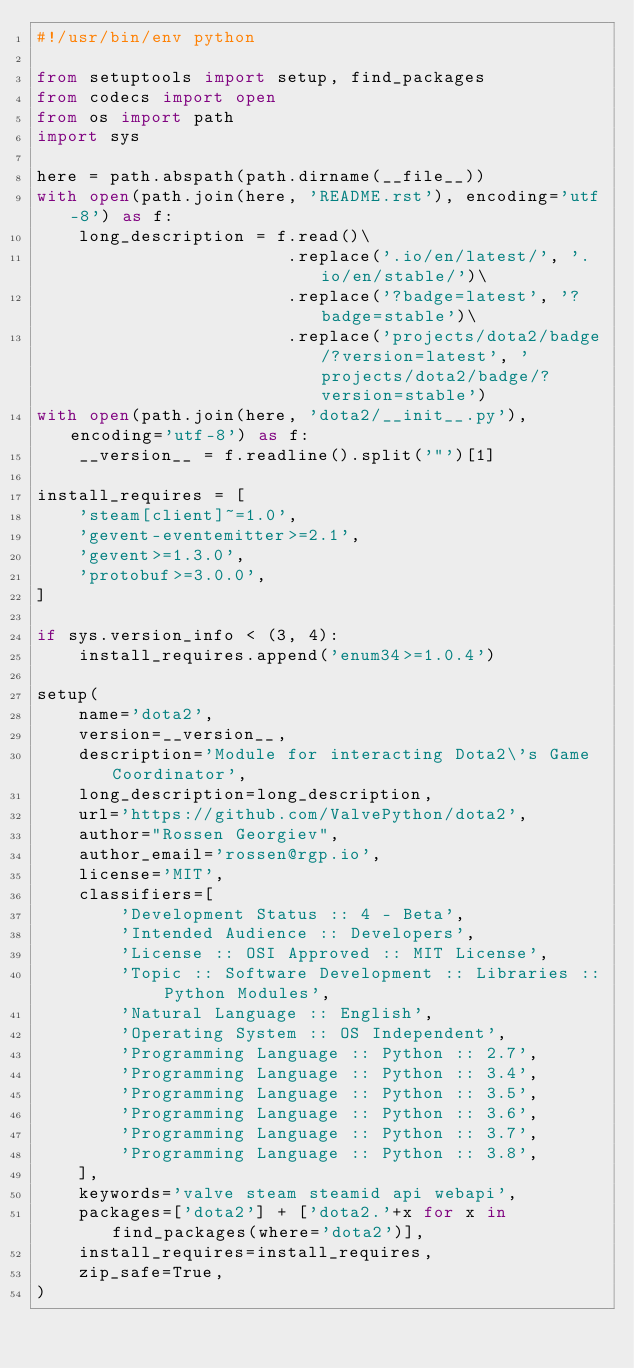<code> <loc_0><loc_0><loc_500><loc_500><_Python_>#!/usr/bin/env python

from setuptools import setup, find_packages
from codecs import open
from os import path
import sys

here = path.abspath(path.dirname(__file__))
with open(path.join(here, 'README.rst'), encoding='utf-8') as f:
    long_description = f.read()\
                        .replace('.io/en/latest/', '.io/en/stable/')\
                        .replace('?badge=latest', '?badge=stable')\
                        .replace('projects/dota2/badge/?version=latest', 'projects/dota2/badge/?version=stable')
with open(path.join(here, 'dota2/__init__.py'), encoding='utf-8') as f:
    __version__ = f.readline().split('"')[1]

install_requires = [
    'steam[client]~=1.0',
    'gevent-eventemitter>=2.1',
    'gevent>=1.3.0',
    'protobuf>=3.0.0',
]

if sys.version_info < (3, 4):
    install_requires.append('enum34>=1.0.4')

setup(
    name='dota2',
    version=__version__,
    description='Module for interacting Dota2\'s Game Coordinator',
    long_description=long_description,
    url='https://github.com/ValvePython/dota2',
    author="Rossen Georgiev",
    author_email='rossen@rgp.io',
    license='MIT',
    classifiers=[
        'Development Status :: 4 - Beta',
        'Intended Audience :: Developers',
        'License :: OSI Approved :: MIT License',
        'Topic :: Software Development :: Libraries :: Python Modules',
        'Natural Language :: English',
        'Operating System :: OS Independent',
        'Programming Language :: Python :: 2.7',
        'Programming Language :: Python :: 3.4',
        'Programming Language :: Python :: 3.5',
        'Programming Language :: Python :: 3.6',
        'Programming Language :: Python :: 3.7',
        'Programming Language :: Python :: 3.8',
    ],
    keywords='valve steam steamid api webapi',
    packages=['dota2'] + ['dota2.'+x for x in find_packages(where='dota2')],
    install_requires=install_requires,
    zip_safe=True,
)
</code> 